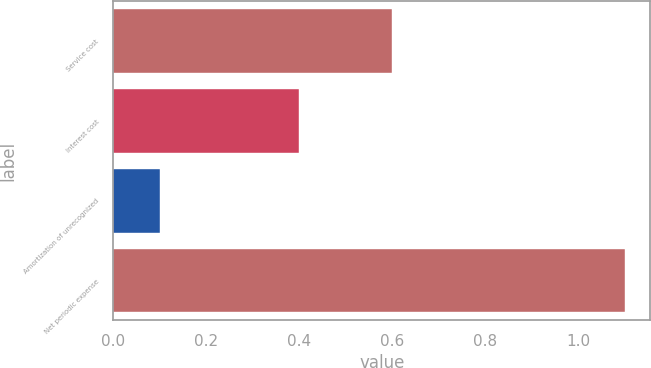Convert chart to OTSL. <chart><loc_0><loc_0><loc_500><loc_500><bar_chart><fcel>Service cost<fcel>Interest cost<fcel>Amortization of unrecognized<fcel>Net periodic expense<nl><fcel>0.6<fcel>0.4<fcel>0.1<fcel>1.1<nl></chart> 